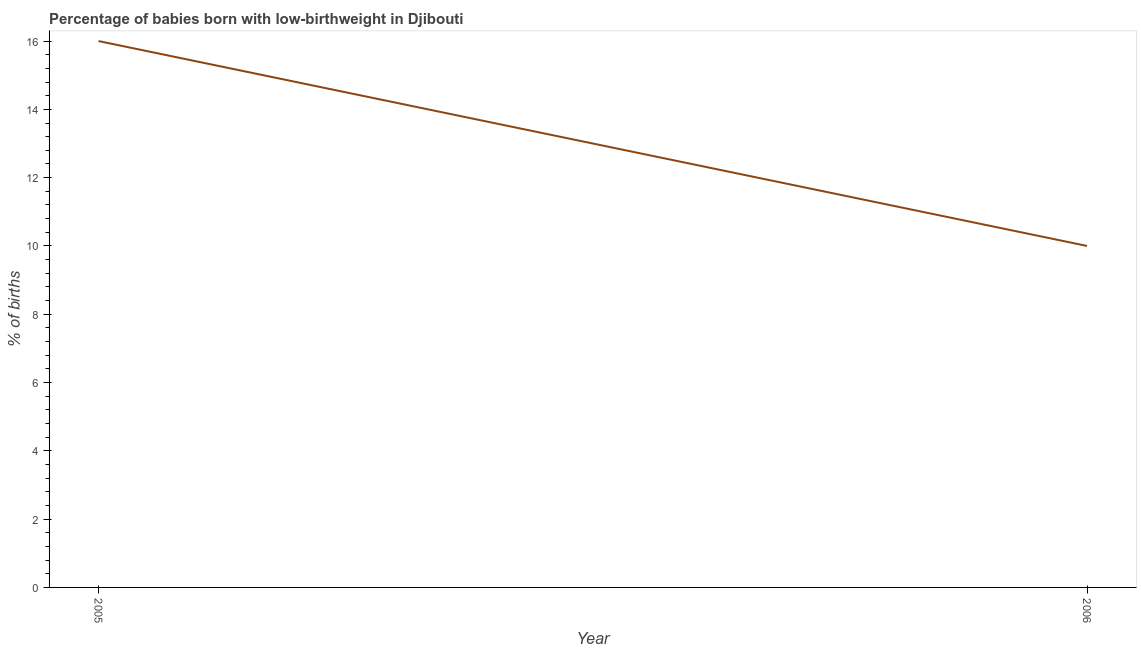What is the percentage of babies who were born with low-birthweight in 2005?
Your response must be concise. 16. Across all years, what is the maximum percentage of babies who were born with low-birthweight?
Offer a very short reply. 16. Across all years, what is the minimum percentage of babies who were born with low-birthweight?
Provide a succinct answer. 10. What is the sum of the percentage of babies who were born with low-birthweight?
Provide a short and direct response. 26. What is the difference between the percentage of babies who were born with low-birthweight in 2005 and 2006?
Your answer should be very brief. 6. In how many years, is the percentage of babies who were born with low-birthweight greater than 4 %?
Give a very brief answer. 2. Do a majority of the years between 2006 and 2005 (inclusive) have percentage of babies who were born with low-birthweight greater than 14.4 %?
Give a very brief answer. No. In how many years, is the percentage of babies who were born with low-birthweight greater than the average percentage of babies who were born with low-birthweight taken over all years?
Offer a terse response. 1. Does the percentage of babies who were born with low-birthweight monotonically increase over the years?
Your answer should be compact. No. What is the title of the graph?
Ensure brevity in your answer.  Percentage of babies born with low-birthweight in Djibouti. What is the label or title of the X-axis?
Provide a succinct answer. Year. What is the label or title of the Y-axis?
Your answer should be very brief. % of births. What is the % of births of 2005?
Provide a succinct answer. 16. What is the % of births of 2006?
Provide a succinct answer. 10. What is the ratio of the % of births in 2005 to that in 2006?
Offer a very short reply. 1.6. 